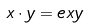Convert formula to latex. <formula><loc_0><loc_0><loc_500><loc_500>x \cdot y = e x y</formula> 